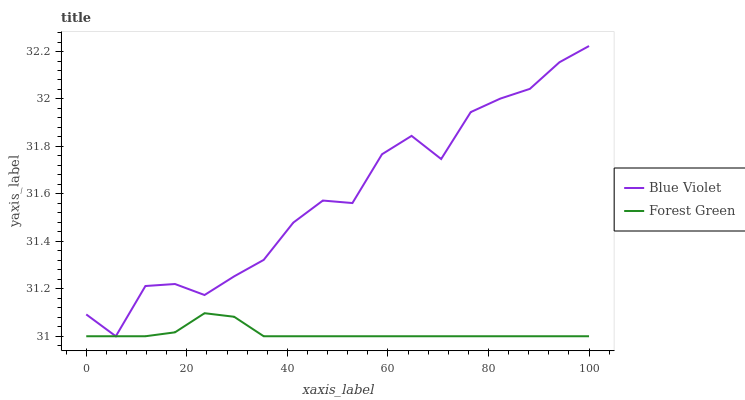Does Forest Green have the minimum area under the curve?
Answer yes or no. Yes. Does Blue Violet have the maximum area under the curve?
Answer yes or no. Yes. Does Blue Violet have the minimum area under the curve?
Answer yes or no. No. Is Forest Green the smoothest?
Answer yes or no. Yes. Is Blue Violet the roughest?
Answer yes or no. Yes. Is Blue Violet the smoothest?
Answer yes or no. No. Does Forest Green have the lowest value?
Answer yes or no. Yes. Does Blue Violet have the highest value?
Answer yes or no. Yes. Does Blue Violet intersect Forest Green?
Answer yes or no. Yes. Is Blue Violet less than Forest Green?
Answer yes or no. No. Is Blue Violet greater than Forest Green?
Answer yes or no. No. 